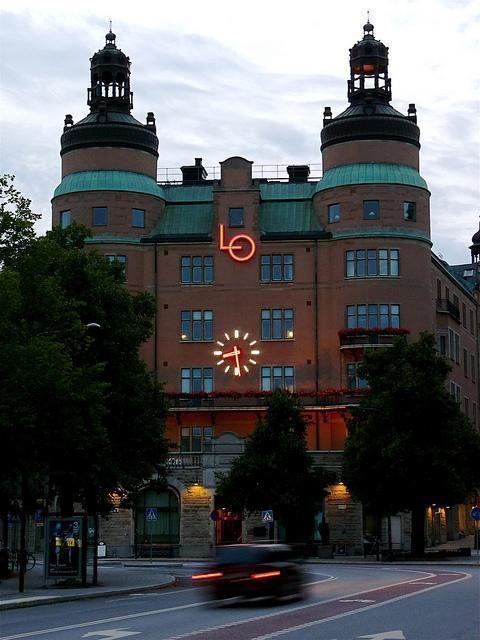What gas causes these lights to glow?
Indicate the correct choice and explain in the format: 'Answer: answer
Rationale: rationale.'
Options: Argon, oxygen, neon, hydrogen. Answer: neon.
Rationale: Signs on a building are lit up. many signs are lit with neon. 